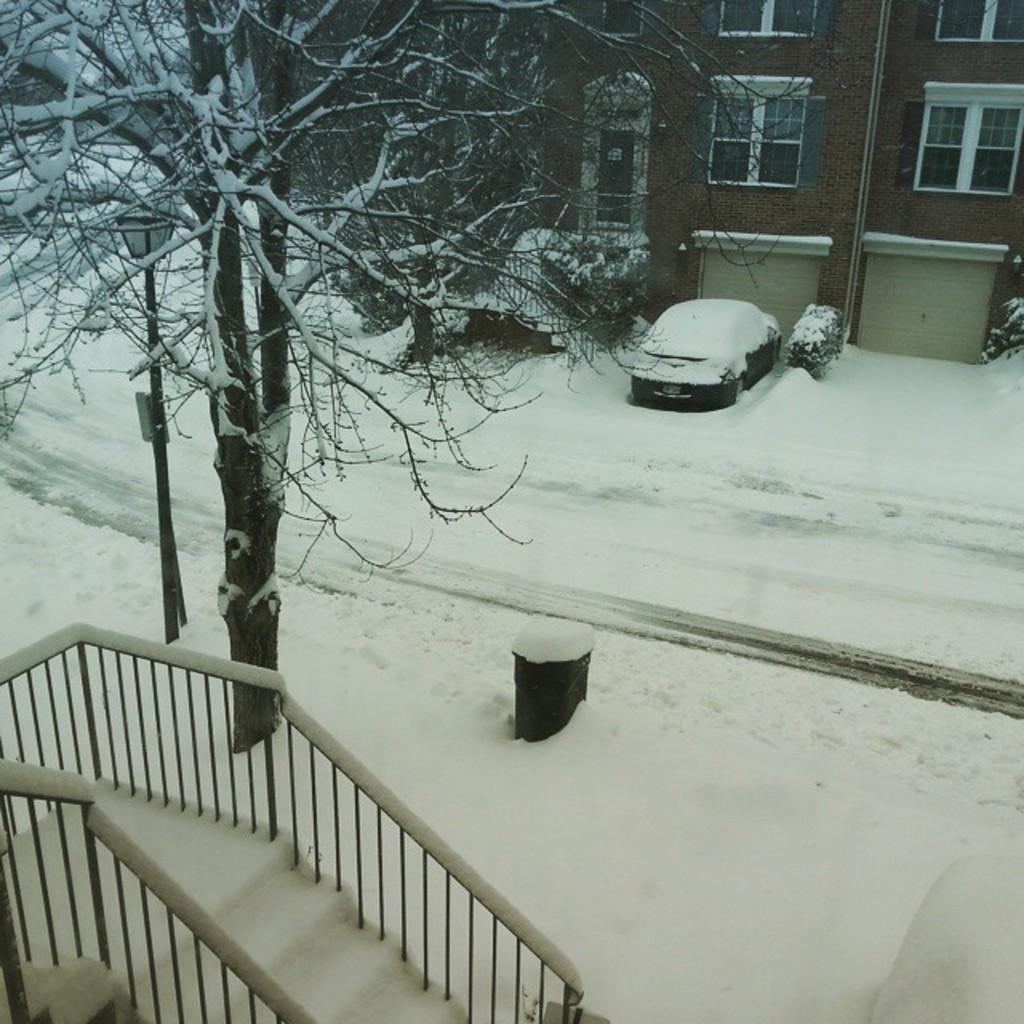What can be seen in the foreground of the image? In the foreground of the image, there are stairs, a tree, and a pole covered with snow. What is visible in the background of the image? In the background of the image, there is a building and a vehicle. What is the weather like in the image? The presence of snow in the image suggests a cold or snowy weather. What type of knife can be seen in the image? There is no knife present in the image. 